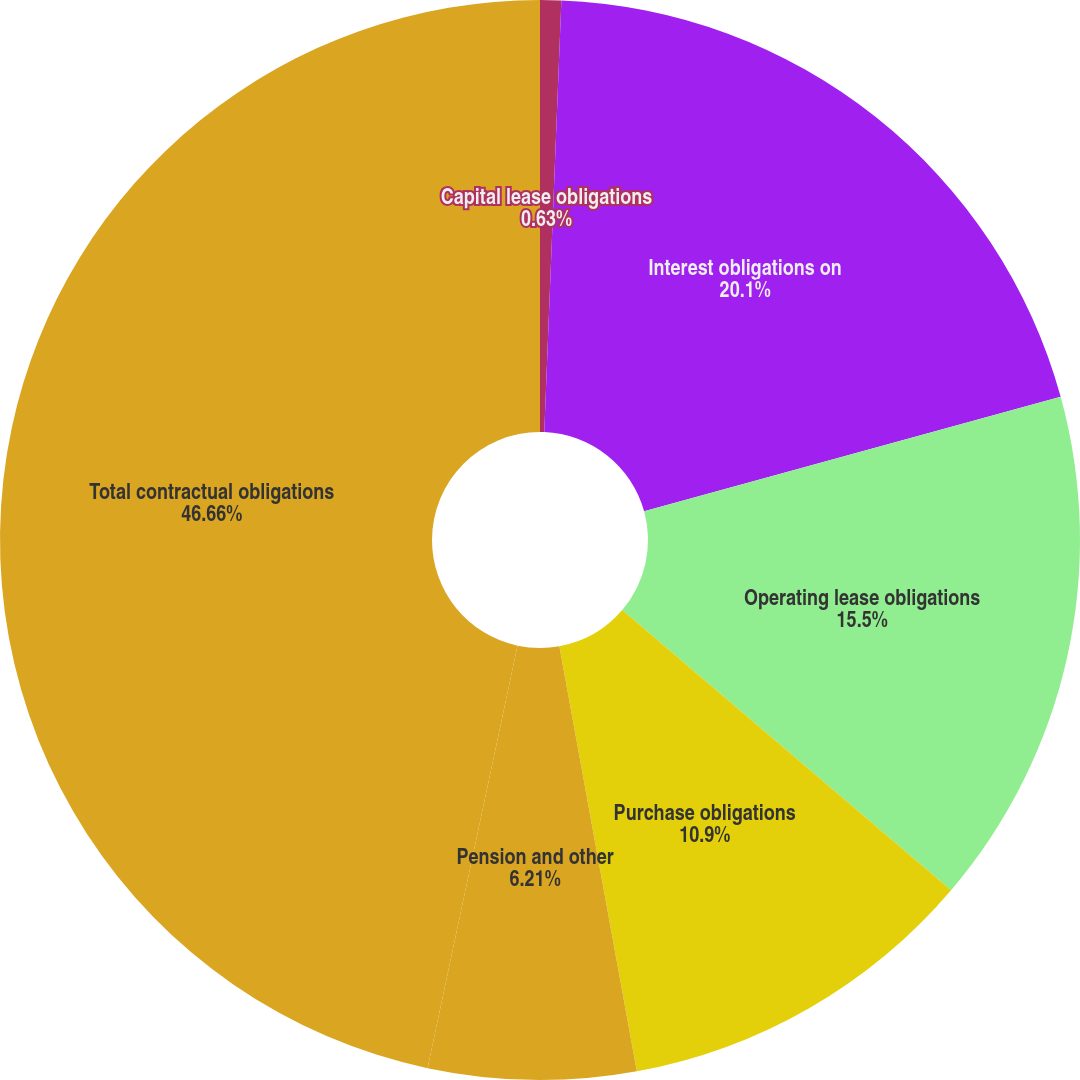Convert chart to OTSL. <chart><loc_0><loc_0><loc_500><loc_500><pie_chart><fcel>Capital lease obligations<fcel>Interest obligations on<fcel>Operating lease obligations<fcel>Purchase obligations<fcel>Pension and other<fcel>Total contractual obligations<nl><fcel>0.63%<fcel>20.1%<fcel>15.5%<fcel>10.9%<fcel>6.21%<fcel>46.66%<nl></chart> 